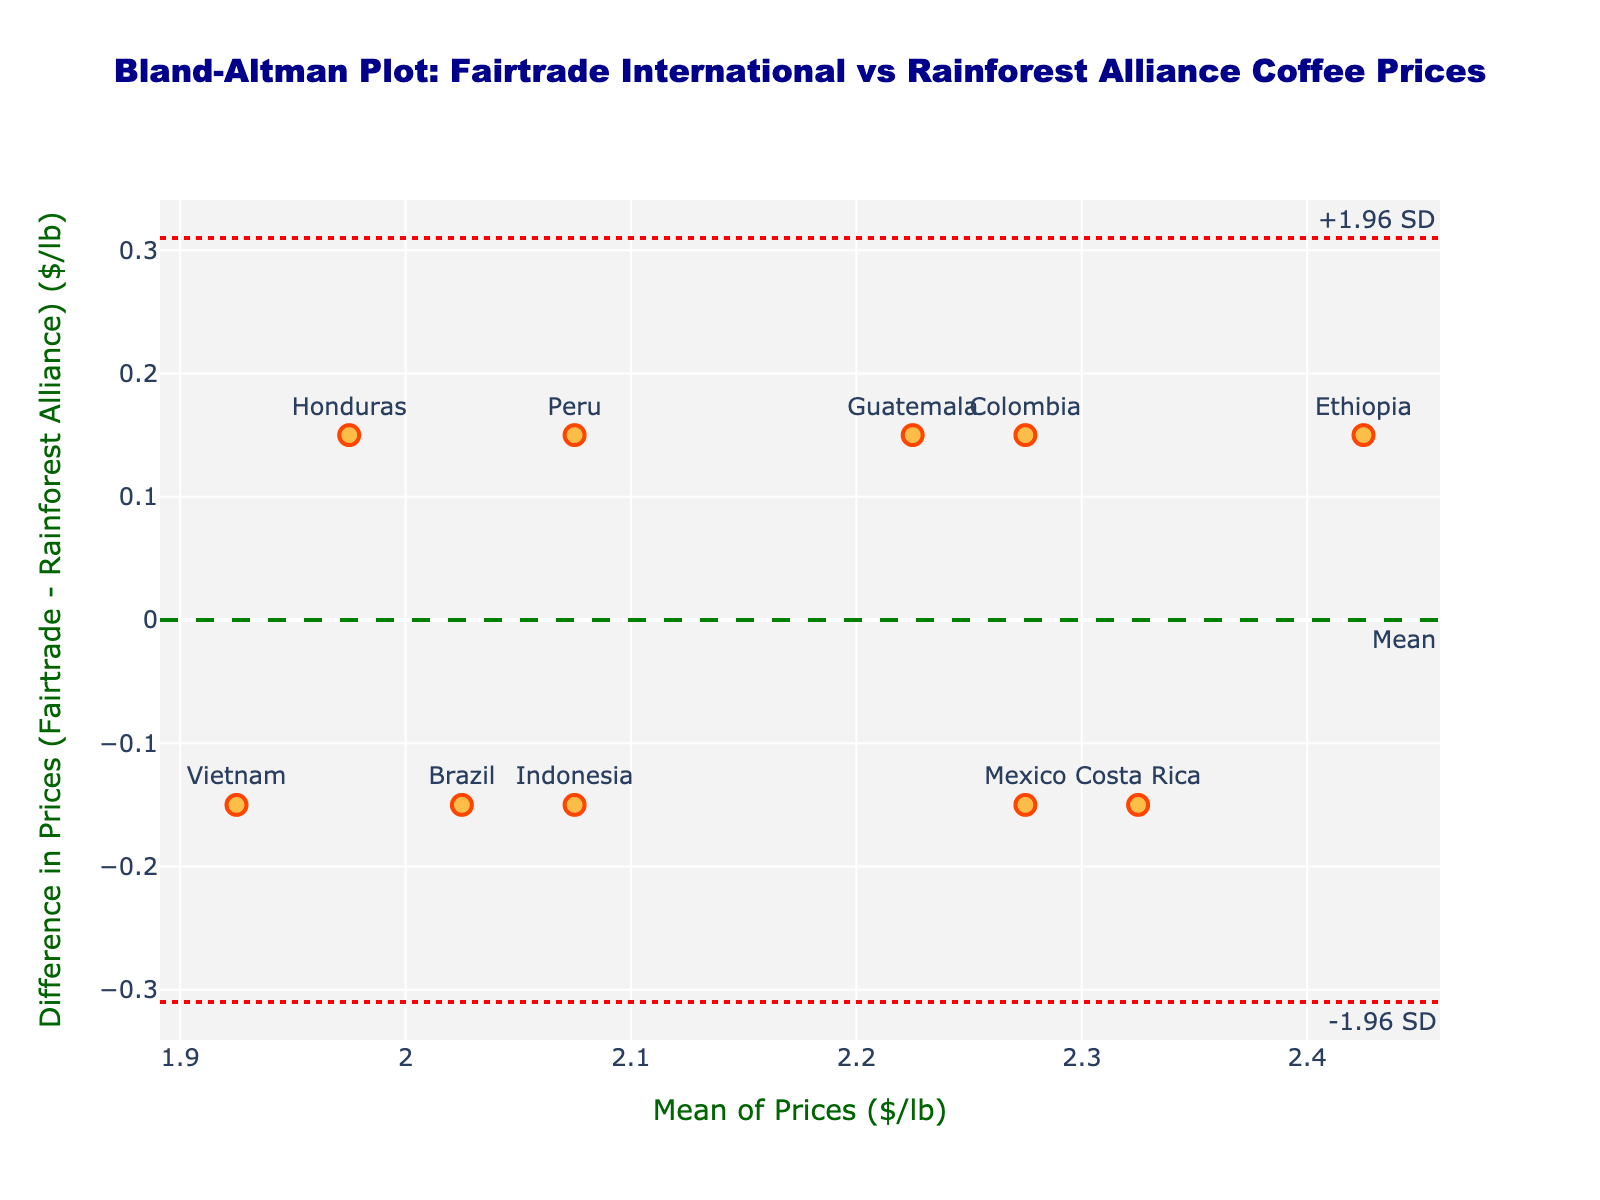what is the title of the plot? The plot title is typically positioned at the top center of the chart. In this case, the title stated in the layout is "Bland-Altman Plot: Fairtrade International vs Rainforest Alliance Coffee Prices".
Answer: Bland-Altman Plot: Fairtrade International vs Rainforest Alliance Coffee Prices what does the y-axis represent? The y-axis label is provided in the layout and states "Difference in Prices (Fairtrade - Rainforest Alliance) ($/lb)". This means it shows the difference between Fairtrade International and Rainforest Alliance prices for each coffee origin.
Answer: Difference in Prices (Fairtrade - Rainforest Alliance) ($/lb) how many data points are shown in the plot? Each data point is represented by a marker. By counting the markers present on the plot, we can ascertain the total number of data points, which, in this case, is 10.
Answer: 10 which coffee origin has the largest positive price difference between Fairtrade and Rainforest Alliance? To find the origin with the largest positive price difference, identify the data point with the highest y-value. Based on the plotted data points and their labels, "Ethiopia" has the highest y-value.
Answer: Ethiopia what is the mean difference in prices depicted by the green dashed line? The green dashed line on the plot represents the mean difference. By referring to the figure, we observe that the line is annotated and positioned at approximately 0.15 on the y-axis.
Answer: 0.15 which two coffee origins have a mean price of $2.05/lb, and what are their differences in prices? Observe the data points aligned vertically at the mean price of $2.05/lb on the x-axis. The labels for these data points are "Peru" and "Honduras". Their y-axis values, representing the price difference (Fairtrade - Rainforest Alliance), are both around 0.15.
Answer: Peru, Honduras; 0.15 what are the limits of agreement on the plot and how are they marked? The limits of agreement are presented as two red dotted lines annotated with "+1.96 SD" and "-1.96 SD". These lines are positioned at y-values approximately equal to 0.30 (upper limit) and -0.01 (lower limit), as indicated by the layout and annotations.
Answer: +0.30 and -0.01 do most of the coffee origins fall within the limits of agreement? By observing the placement of all data points in relation to the red dotted lines (limits of agreement), we can determine if they fall within this range. Most data points do indeed fall within the upper and lower red dotted lines.
Answer: Yes which coffee origin has the smallest price difference and what is the mean price? By identifying the data point closest to a y-value of 0, we find the origin with the smallest price difference. In this case, "Brazil" is closest to 0 on the y-axis, and its mean price, as shown on the x-axis, is around $2.03/lb.
Answer: Brazil; $2.03/lb 